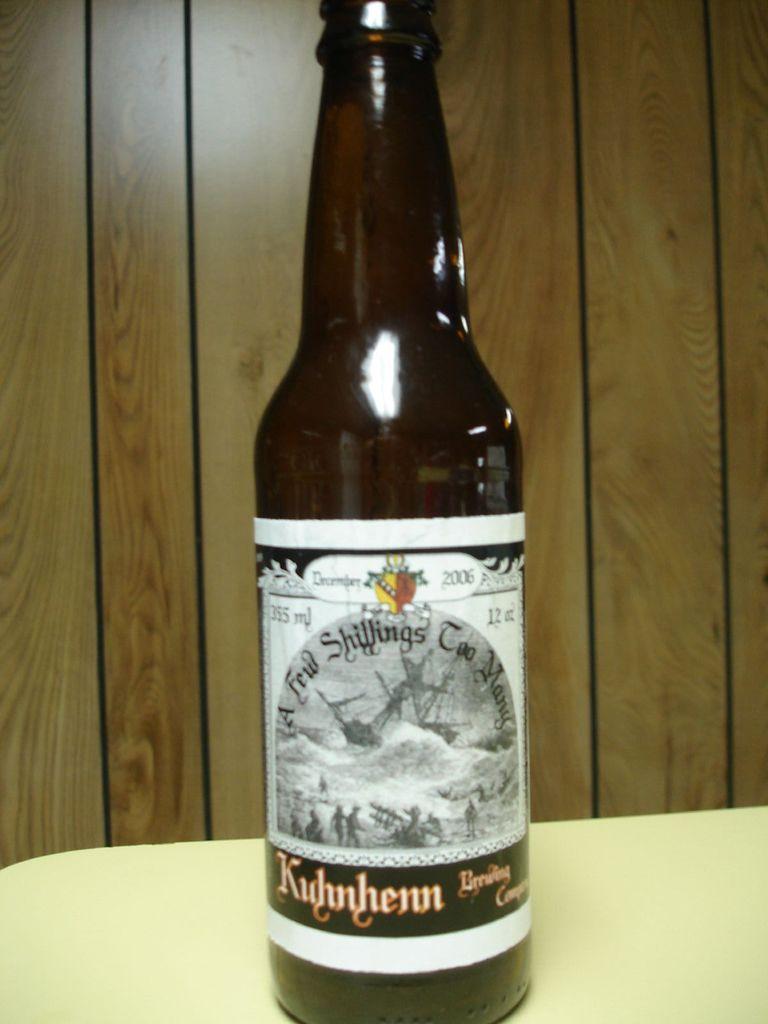A few what too many?
Offer a very short reply. Unanswerable. 